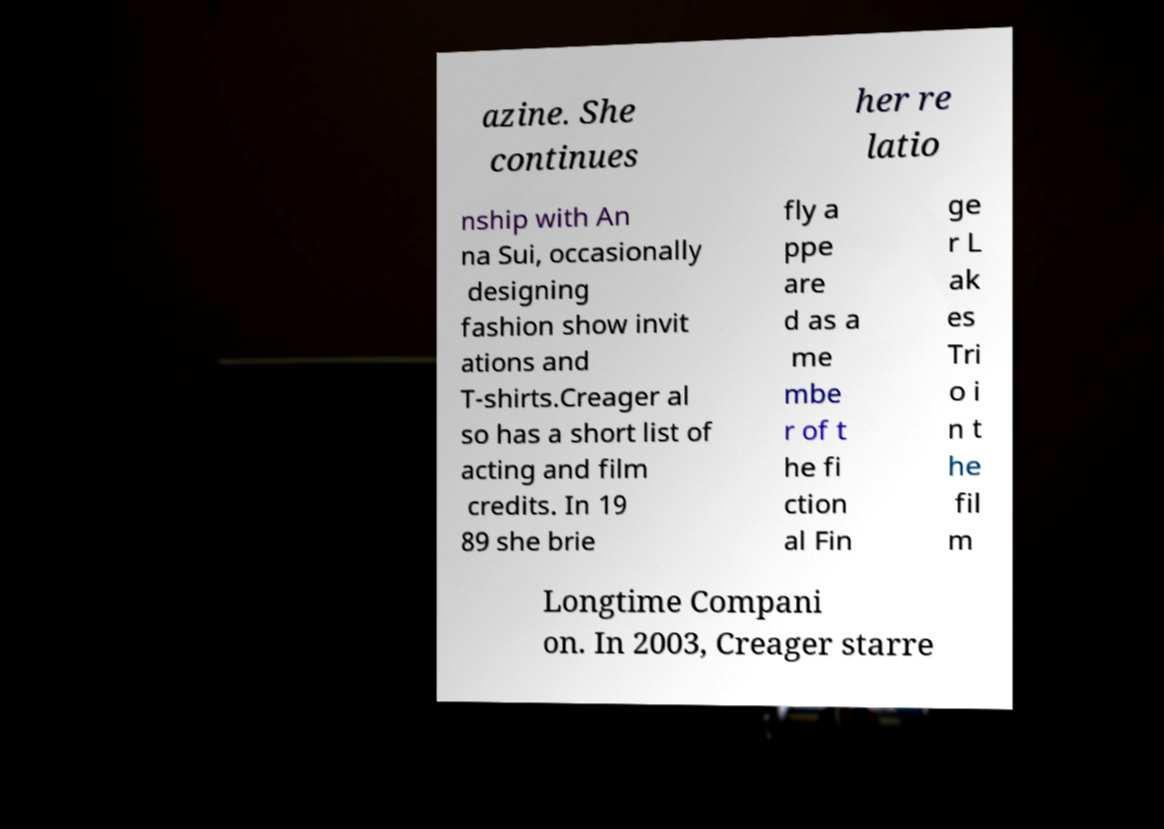For documentation purposes, I need the text within this image transcribed. Could you provide that? azine. She continues her re latio nship with An na Sui, occasionally designing fashion show invit ations and T-shirts.Creager al so has a short list of acting and film credits. In 19 89 she brie fly a ppe are d as a me mbe r of t he fi ction al Fin ge r L ak es Tri o i n t he fil m Longtime Compani on. In 2003, Creager starre 